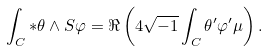Convert formula to latex. <formula><loc_0><loc_0><loc_500><loc_500>\int _ { C } \ast \theta \wedge S \varphi = \Re \left ( 4 \sqrt { - 1 } \int _ { C } \theta ^ { \prime } \varphi ^ { \prime } \mu \right ) .</formula> 